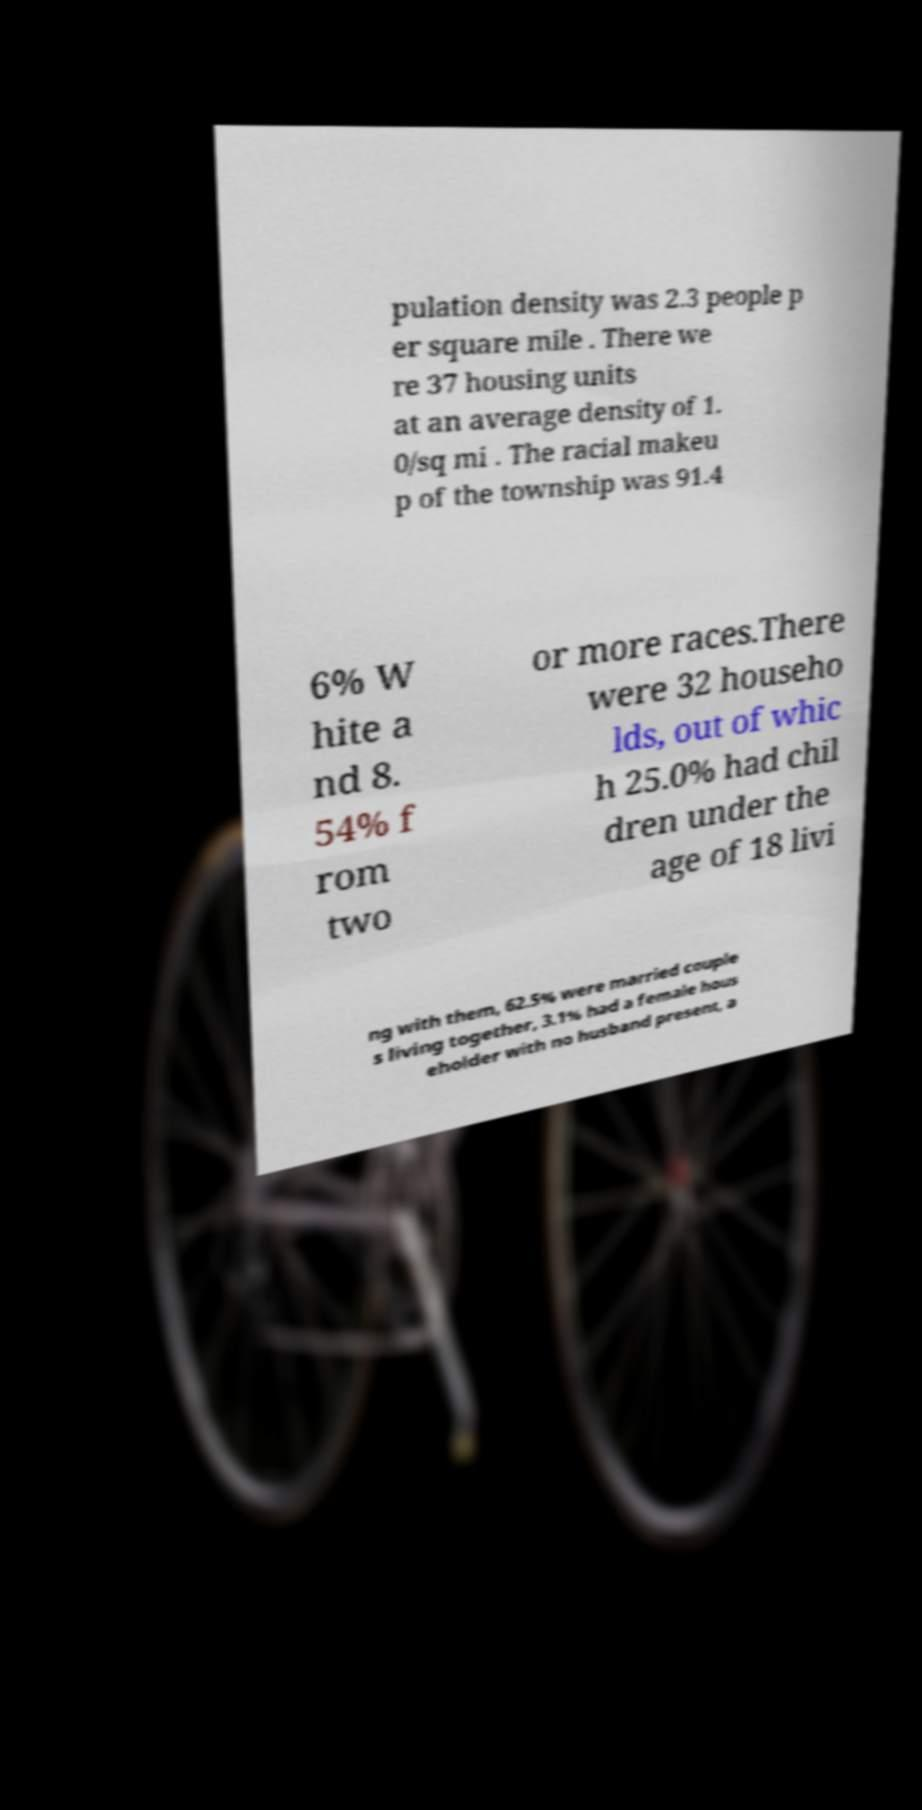Can you read and provide the text displayed in the image?This photo seems to have some interesting text. Can you extract and type it out for me? pulation density was 2.3 people p er square mile . There we re 37 housing units at an average density of 1. 0/sq mi . The racial makeu p of the township was 91.4 6% W hite a nd 8. 54% f rom two or more races.There were 32 househo lds, out of whic h 25.0% had chil dren under the age of 18 livi ng with them, 62.5% were married couple s living together, 3.1% had a female hous eholder with no husband present, a 